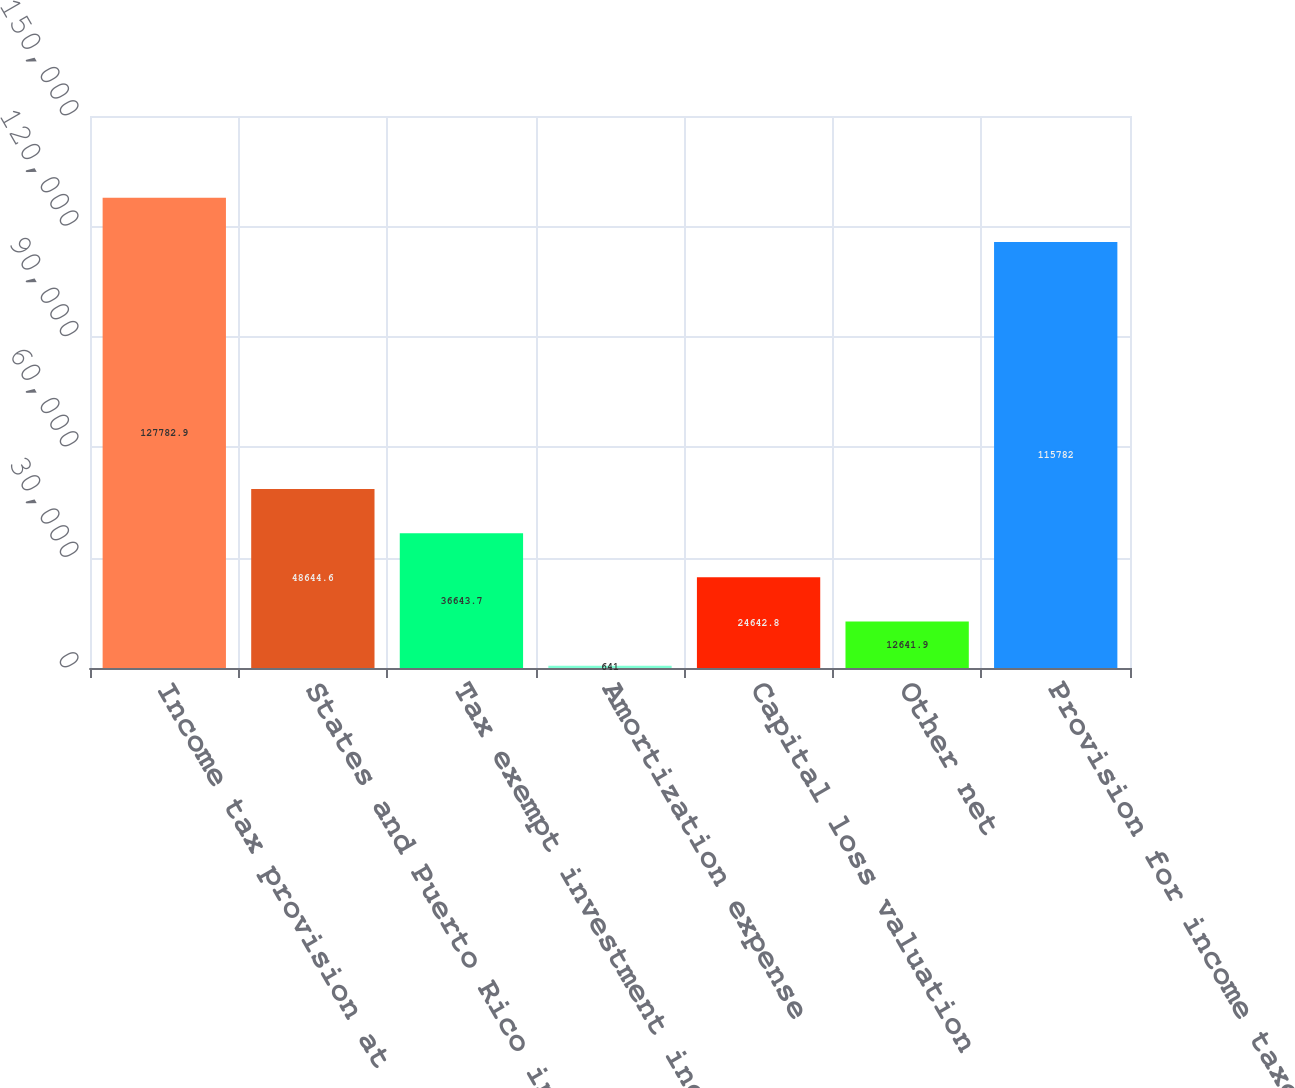Convert chart. <chart><loc_0><loc_0><loc_500><loc_500><bar_chart><fcel>Income tax provision at<fcel>States and Puerto Rico income<fcel>Tax exempt investment income<fcel>Amortization expense<fcel>Capital loss valuation<fcel>Other net<fcel>Provision for income taxes<nl><fcel>127783<fcel>48644.6<fcel>36643.7<fcel>641<fcel>24642.8<fcel>12641.9<fcel>115782<nl></chart> 